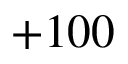<formula> <loc_0><loc_0><loc_500><loc_500>+ 1 0 0</formula> 